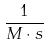<formula> <loc_0><loc_0><loc_500><loc_500>\frac { 1 } { M \cdot s }</formula> 